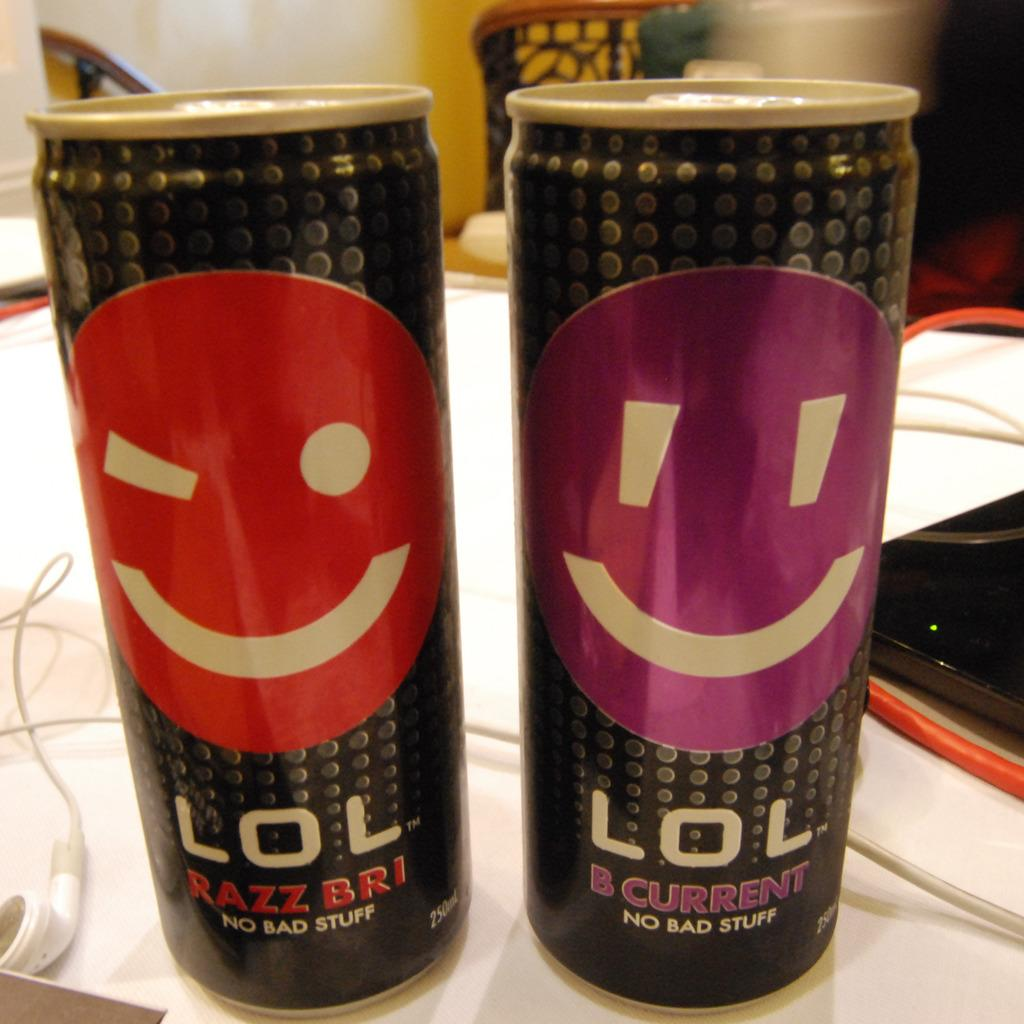<image>
Present a compact description of the photo's key features. Two cans of LOL beverage sit on a desk. 